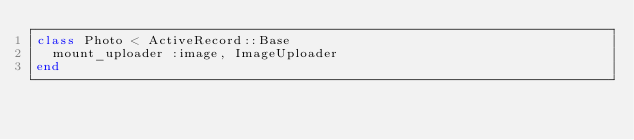Convert code to text. <code><loc_0><loc_0><loc_500><loc_500><_Ruby_>class Photo < ActiveRecord::Base
  mount_uploader :image, ImageUploader
end
</code> 